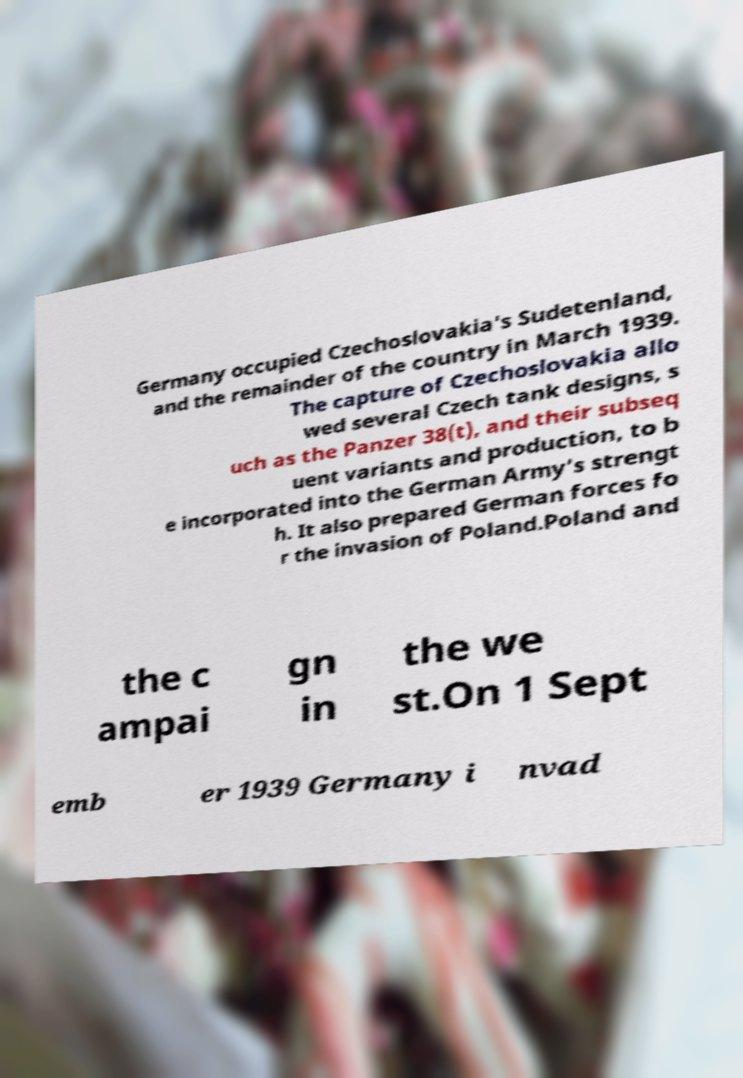Please identify and transcribe the text found in this image. Germany occupied Czechoslovakia's Sudetenland, and the remainder of the country in March 1939. The capture of Czechoslovakia allo wed several Czech tank designs, s uch as the Panzer 38(t), and their subseq uent variants and production, to b e incorporated into the German Army's strengt h. It also prepared German forces fo r the invasion of Poland.Poland and the c ampai gn in the we st.On 1 Sept emb er 1939 Germany i nvad 